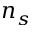<formula> <loc_0><loc_0><loc_500><loc_500>n _ { s }</formula> 